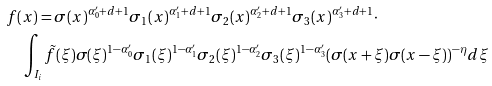Convert formula to latex. <formula><loc_0><loc_0><loc_500><loc_500>& f ( x ) = \sigma ( x ) ^ { \alpha ^ { \prime } _ { 0 } + d + 1 } \sigma _ { 1 } ( x ) ^ { \alpha ^ { \prime } _ { 1 } + d + 1 } \sigma _ { 2 } ( x ) ^ { \alpha ^ { \prime } _ { 2 } + d + 1 } \sigma _ { 3 } ( x ) ^ { \alpha ^ { \prime } _ { 3 } + d + 1 } \cdot \\ & \quad \int _ { I _ { i } } \tilde { f } ( \xi ) \sigma ( \xi ) ^ { 1 - \alpha ^ { \prime } _ { 0 } } \sigma _ { 1 } ( \xi ) ^ { 1 - \alpha ^ { \prime } _ { 1 } } \sigma _ { 2 } ( \xi ) ^ { 1 - \alpha ^ { \prime } _ { 2 } } \sigma _ { 3 } ( \xi ) ^ { 1 - \alpha ^ { \prime } _ { 3 } } ( \sigma ( x + \xi ) \sigma ( x - \xi ) ) ^ { - \eta } d \xi</formula> 